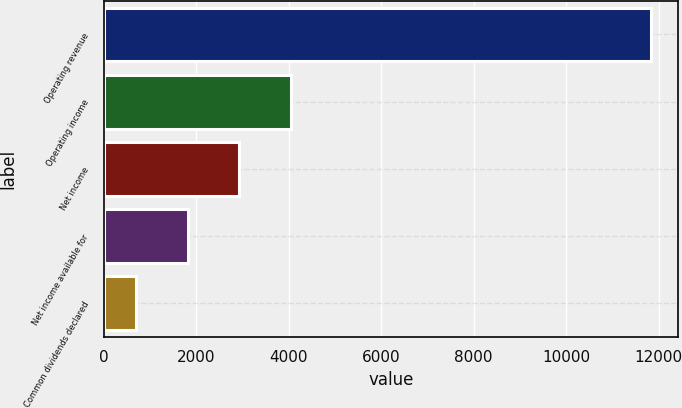<chart> <loc_0><loc_0><loc_500><loc_500><bar_chart><fcel>Operating revenue<fcel>Operating income<fcel>Net income<fcel>Net income available for<fcel>Common dividends declared<nl><fcel>11830<fcel>4039.7<fcel>2926.8<fcel>1813.9<fcel>701<nl></chart> 